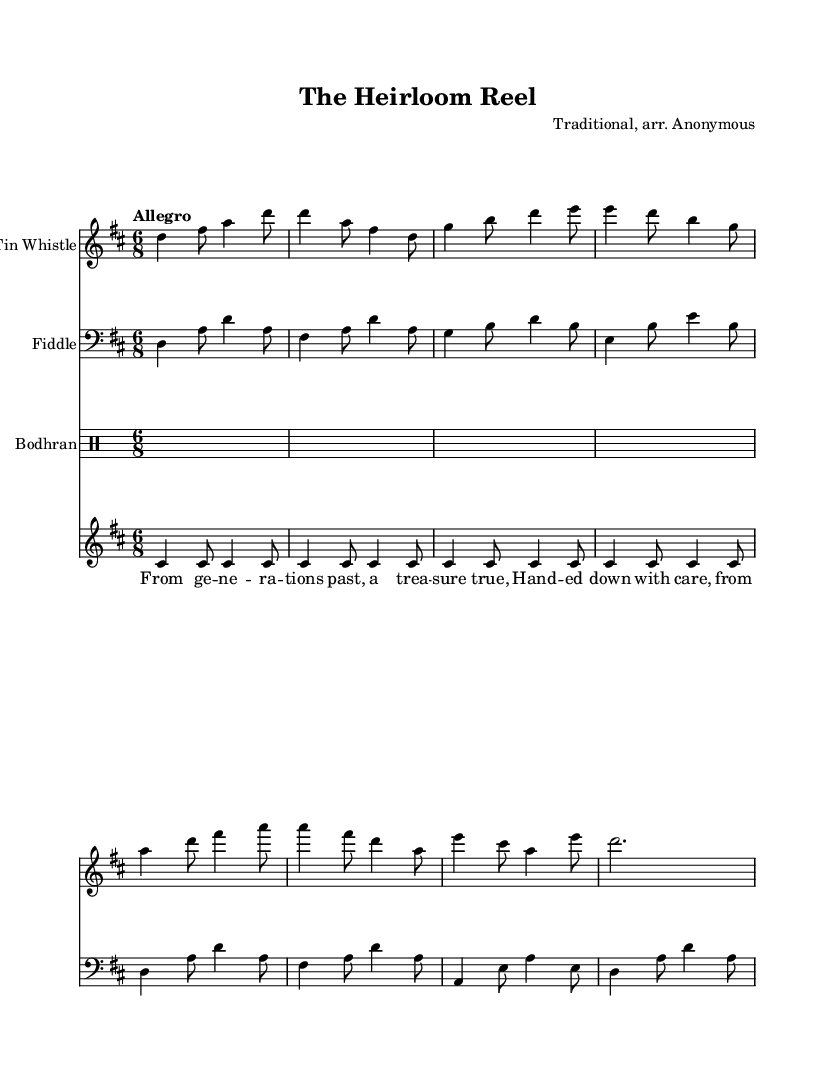What is the key signature of this music? The key signature is indicated at the beginning of the music with sharps or flats. In this case, there are two sharps (F# and C#), which define the key as D major.
Answer: D major What is the time signature of this piece? The time signature is displayed at the start of the sheet music, represented as 6 over 8. This indicates that there are six eighth notes in each measure.
Answer: 6/8 What is the tempo marking for this music? The tempo marking is specified at the beginning of the score and indicates the speed of the piece. Here, "Allegro" suggests a fast and lively tempo.
Answer: Allegro Which instrument is playing the melody? The melody is typically assigned to one instrument, here it is evident from the scoring that the Tin Whistle carries the main melody line.
Answer: Tin Whistle How many measures are shown in the score? To determine the number of measures, one must count each segment separated by vertical lines on the staff. In this score, there are 16 measures visible.
Answer: 16 What theme does this piece convey regarding legacy? The lyrics clearly articulate themes of passing down treasures and heritage, suggesting a focus on generational connections and inheritance.
Answer: Legacy Which instruments are included in the score? The sheet music lists various instruments at the beginning of each staff. The instruments present are the Tin Whistle, Fiddle, and Bodhran.
Answer: Tin Whistle, Fiddle, Bodhran 